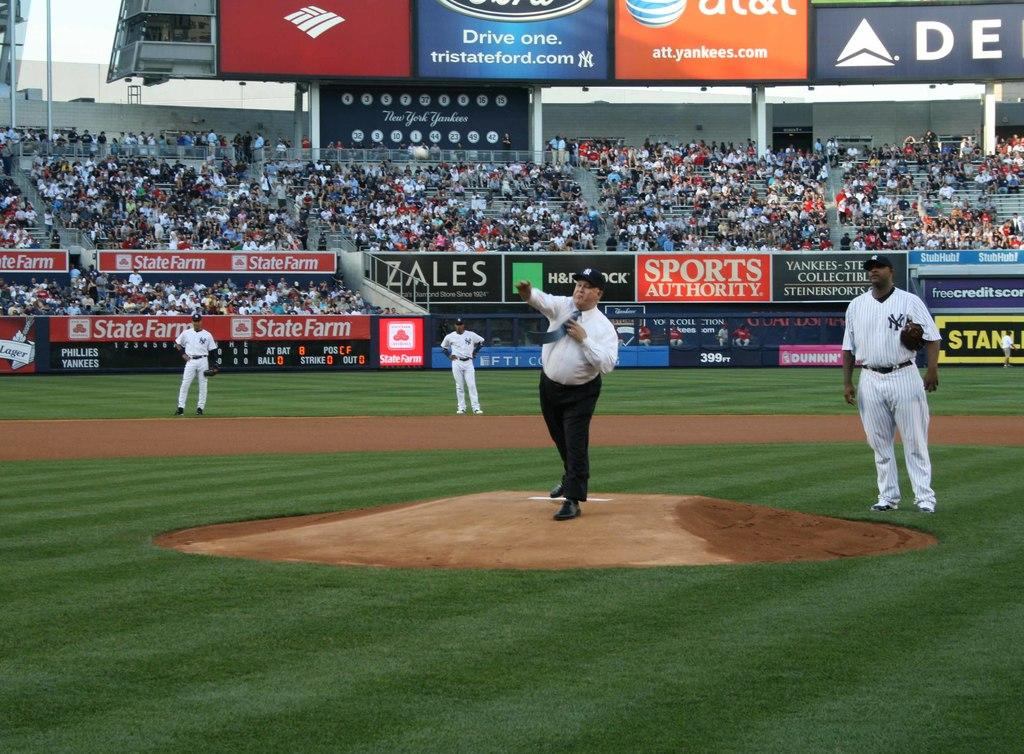<image>
Share a concise interpretation of the image provided. a baseball field with a side banner that says 'sports authority' 